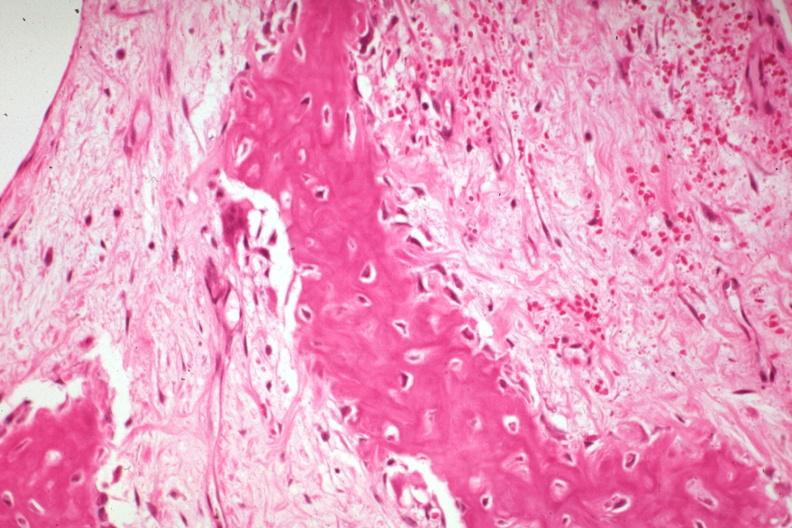s joints present?
Answer the question using a single word or phrase. Yes 